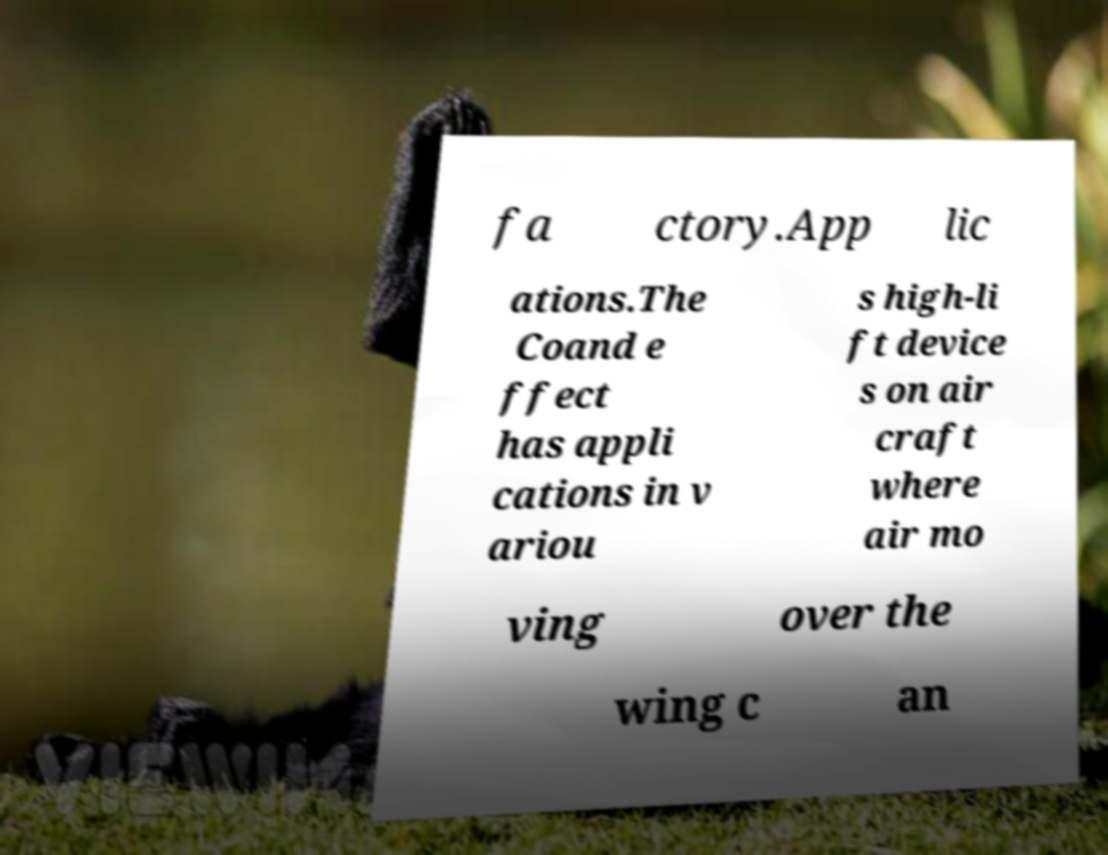I need the written content from this picture converted into text. Can you do that? fa ctory.App lic ations.The Coand e ffect has appli cations in v ariou s high-li ft device s on air craft where air mo ving over the wing c an 